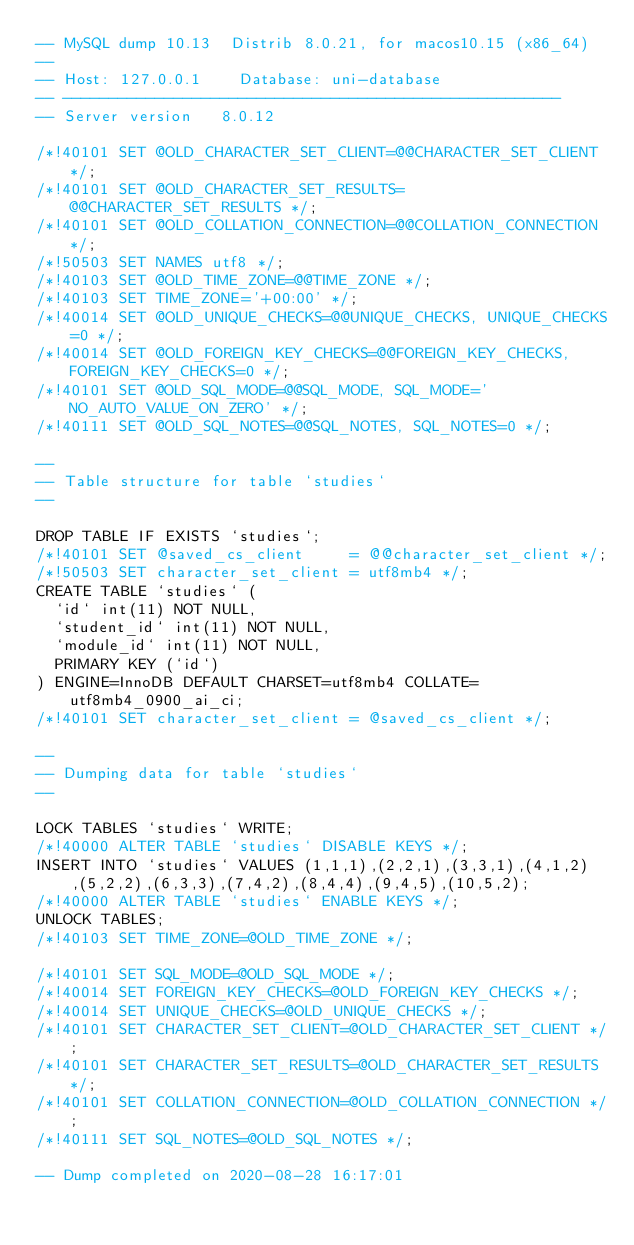<code> <loc_0><loc_0><loc_500><loc_500><_SQL_>-- MySQL dump 10.13  Distrib 8.0.21, for macos10.15 (x86_64)
--
-- Host: 127.0.0.1    Database: uni-database
-- ------------------------------------------------------
-- Server version	8.0.12

/*!40101 SET @OLD_CHARACTER_SET_CLIENT=@@CHARACTER_SET_CLIENT */;
/*!40101 SET @OLD_CHARACTER_SET_RESULTS=@@CHARACTER_SET_RESULTS */;
/*!40101 SET @OLD_COLLATION_CONNECTION=@@COLLATION_CONNECTION */;
/*!50503 SET NAMES utf8 */;
/*!40103 SET @OLD_TIME_ZONE=@@TIME_ZONE */;
/*!40103 SET TIME_ZONE='+00:00' */;
/*!40014 SET @OLD_UNIQUE_CHECKS=@@UNIQUE_CHECKS, UNIQUE_CHECKS=0 */;
/*!40014 SET @OLD_FOREIGN_KEY_CHECKS=@@FOREIGN_KEY_CHECKS, FOREIGN_KEY_CHECKS=0 */;
/*!40101 SET @OLD_SQL_MODE=@@SQL_MODE, SQL_MODE='NO_AUTO_VALUE_ON_ZERO' */;
/*!40111 SET @OLD_SQL_NOTES=@@SQL_NOTES, SQL_NOTES=0 */;

--
-- Table structure for table `studies`
--

DROP TABLE IF EXISTS `studies`;
/*!40101 SET @saved_cs_client     = @@character_set_client */;
/*!50503 SET character_set_client = utf8mb4 */;
CREATE TABLE `studies` (
  `id` int(11) NOT NULL,
  `student_id` int(11) NOT NULL,
  `module_id` int(11) NOT NULL,
  PRIMARY KEY (`id`)
) ENGINE=InnoDB DEFAULT CHARSET=utf8mb4 COLLATE=utf8mb4_0900_ai_ci;
/*!40101 SET character_set_client = @saved_cs_client */;

--
-- Dumping data for table `studies`
--

LOCK TABLES `studies` WRITE;
/*!40000 ALTER TABLE `studies` DISABLE KEYS */;
INSERT INTO `studies` VALUES (1,1,1),(2,2,1),(3,3,1),(4,1,2),(5,2,2),(6,3,3),(7,4,2),(8,4,4),(9,4,5),(10,5,2);
/*!40000 ALTER TABLE `studies` ENABLE KEYS */;
UNLOCK TABLES;
/*!40103 SET TIME_ZONE=@OLD_TIME_ZONE */;

/*!40101 SET SQL_MODE=@OLD_SQL_MODE */;
/*!40014 SET FOREIGN_KEY_CHECKS=@OLD_FOREIGN_KEY_CHECKS */;
/*!40014 SET UNIQUE_CHECKS=@OLD_UNIQUE_CHECKS */;
/*!40101 SET CHARACTER_SET_CLIENT=@OLD_CHARACTER_SET_CLIENT */;
/*!40101 SET CHARACTER_SET_RESULTS=@OLD_CHARACTER_SET_RESULTS */;
/*!40101 SET COLLATION_CONNECTION=@OLD_COLLATION_CONNECTION */;
/*!40111 SET SQL_NOTES=@OLD_SQL_NOTES */;

-- Dump completed on 2020-08-28 16:17:01
</code> 